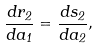<formula> <loc_0><loc_0><loc_500><loc_500>\frac { d r _ { 2 } } { d a _ { 1 } } = \frac { d s _ { 2 } } { d a _ { 2 } } ,</formula> 